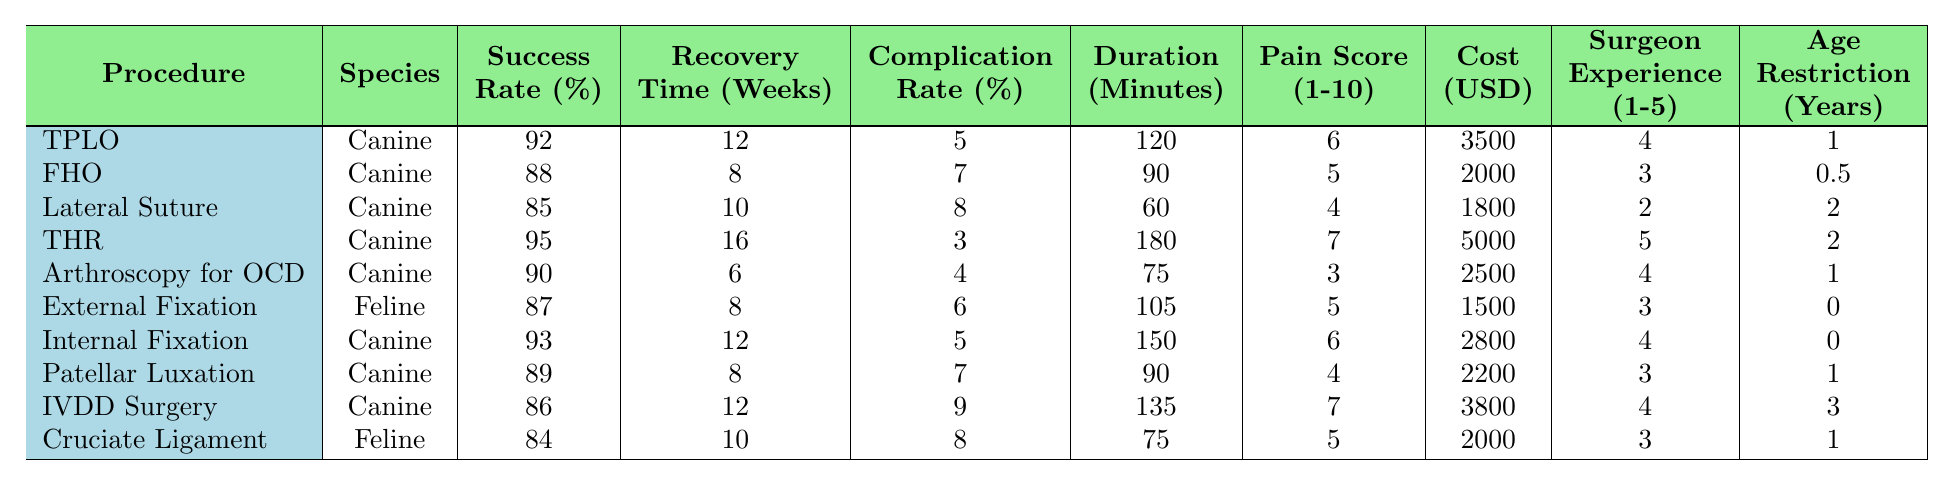What is the success rate for Total Hip Replacement (THR)? The table shows the success rate for THR in the corresponding row, which is listed as 95%.
Answer: 95% Which procedure has the lowest complication rate percentage? By reviewing the complication rate percentages, Total Hip Replacement has the lowest rate at 3%.
Answer: 3% What is the average recovery time for Fracture Repair with External Fixation? The recovery time for Fracture Repair - External Fixation is shown as 8 weeks in the table.
Answer: 8 weeks How much does Arthroscopy for OCD cost? The estimated cost for Arthroscopy for OCD is listed as 2500 USD in the table.
Answer: 2500 USD Which procedure requires the most time to perform, and how long does it take? The procedure with the longest duration is Total Hip Replacement, which takes 180 minutes as indicated in the table.
Answer: 180 minutes Is the success rate for Tibial Plateau Leveling Osteotomy higher than that of Patellar Luxation Correction? The success rate for Tibial Plateau Leveling Osteotomy is 92%, while Patellar Luxation Correction is 89%—making TPLO higher.
Answer: Yes What is the average pain score for Lateral Suture Stabilization? The table lists the pain score for Lateral Suture Stabilization as 4.
Answer: 4 Which procedures have a success rate greater than 90%? The procedures with a success rate greater than 90% are Tibial Plateau Leveling Osteotomy (92%), Total Hip Replacement (95%), and Internal Fixation (93%).
Answer: TPLO, THR, Internal Fixation How does the average recovery time of Fracture Repair - Internal Fixation compare to that of IVDD Surgery? Fracture Repair - Internal Fixation has an average recovery time of 12 weeks, while IVDD Surgery has 12 weeks, which are equal.
Answer: Equal What is the average surgeon experience level requirement for all the listed procedures? To find the average, sum the experience levels (4 + 3 + 2 + 5 + 4 + 3 + 4 + 3 + 4 + 3 = 39) and divide by the number of procedures (10), resulting in an average of 3.9.
Answer: 3.9 What is the relationship between complication rate and success rate for the procedures listed? Analyzing the table shows that lower complication rates, such as in Total Hip Replacement (3%), generally correlate with higher success rates (95%). Conversely, procedures like Lateral Suture Stabilization and Cruciate Ligament Repair both show higher complication rates (8% and 8%, respectively) and lower success rates (85% and 84%).
Answer: Generally negative correlation 